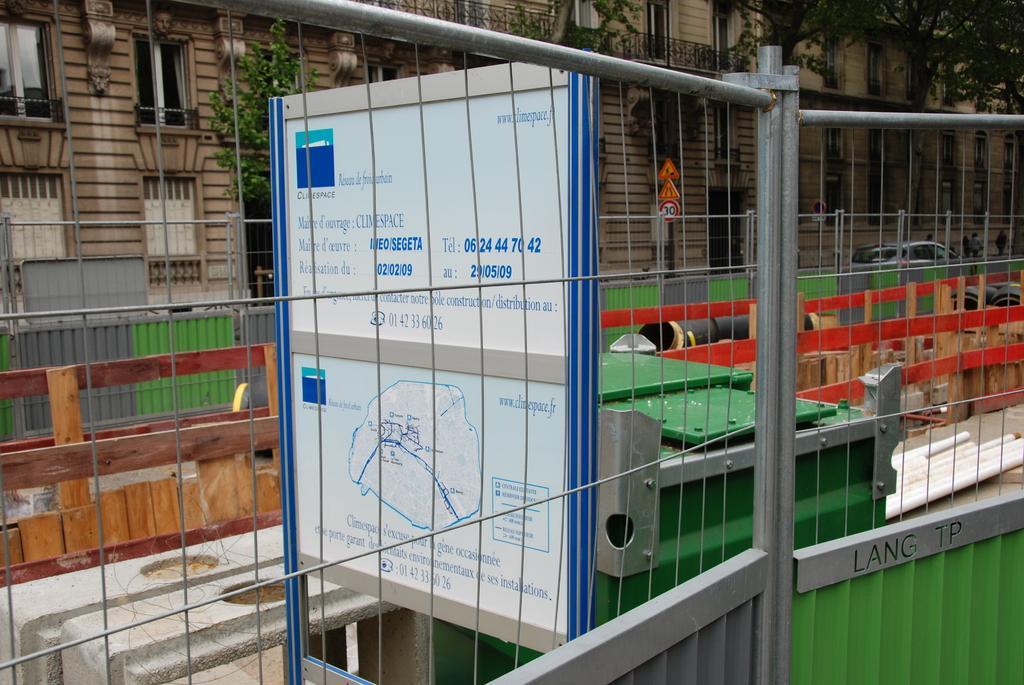Please provide a concise description of this image. In this image we can see buildings, windows, trees, sign boards, motor vehicles, iron grill, information boards and a bin. 